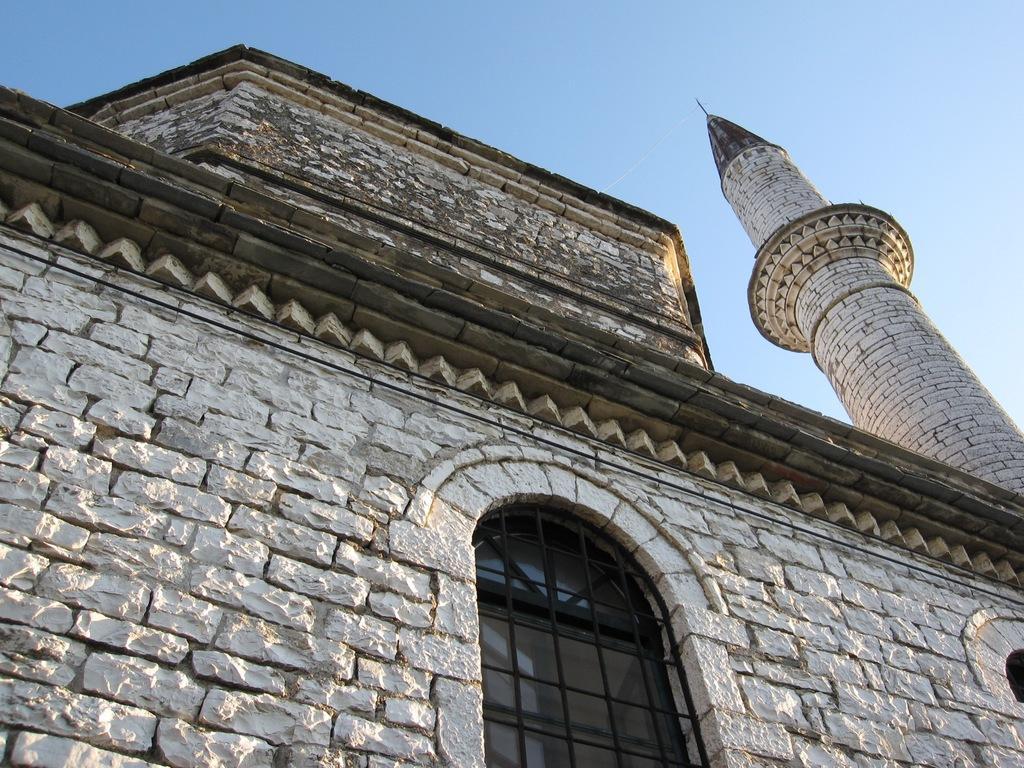Can you describe this image briefly? In this image, we can see a building's, walls, glass window, grill and tower. Background we can see the sky. 